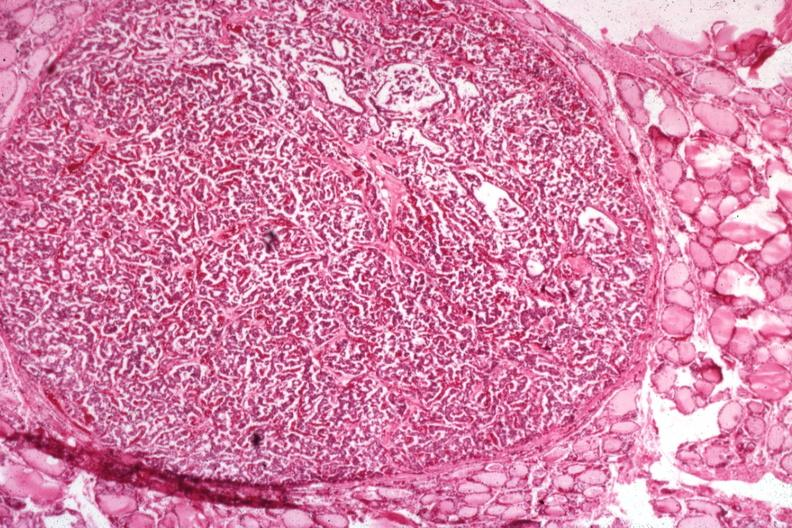what is present?
Answer the question using a single word or phrase. Endocrine 